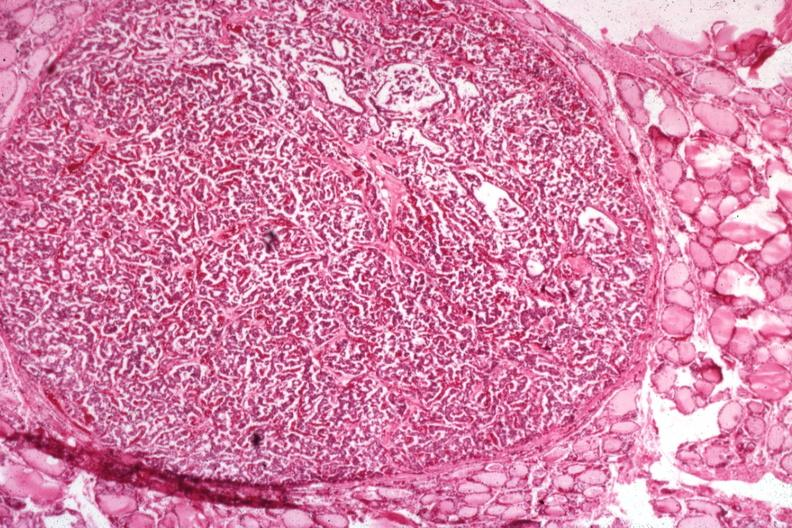what is present?
Answer the question using a single word or phrase. Endocrine 